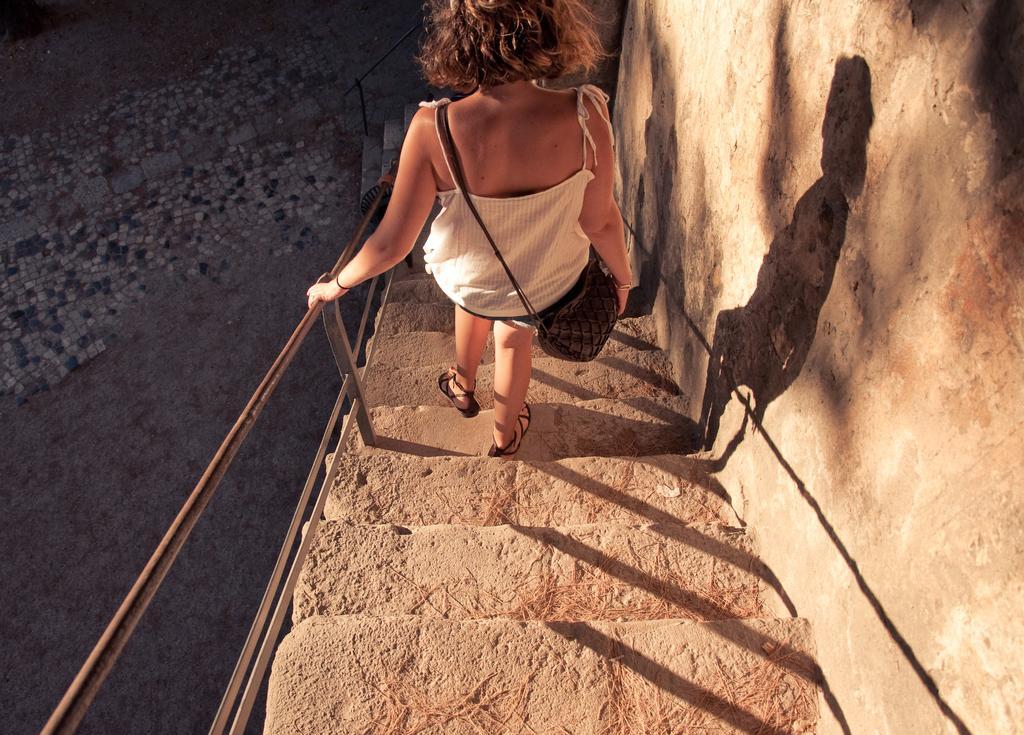Could you give a brief overview of what you see in this image? In the image we can see a woman wearing clothes, sandals and she is carrying a handbag. She is walking on the steps, here we can see stairs, fence, wall and the footpath. 